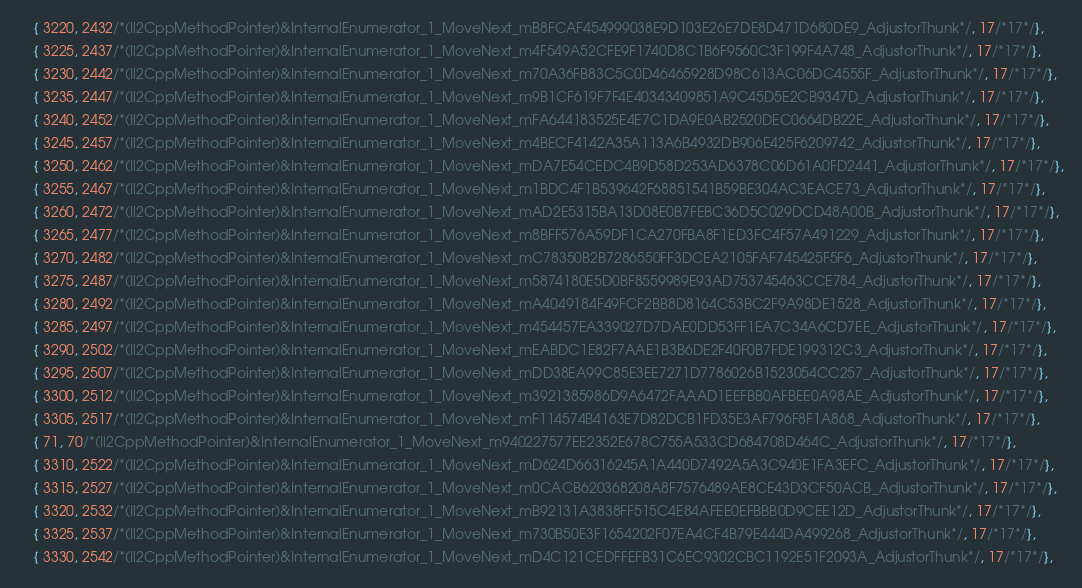Convert code to text. <code><loc_0><loc_0><loc_500><loc_500><_C++_>	{ 3220, 2432/*(Il2CppMethodPointer)&InternalEnumerator_1_MoveNext_mB8FCAF454999038E9D103E26E7DE8D471D680DE9_AdjustorThunk*/, 17/*17*/},
	{ 3225, 2437/*(Il2CppMethodPointer)&InternalEnumerator_1_MoveNext_m4F549A52CFE9F1740D8C1B6F9560C3F199F4A748_AdjustorThunk*/, 17/*17*/},
	{ 3230, 2442/*(Il2CppMethodPointer)&InternalEnumerator_1_MoveNext_m70A36FB83C5C0D46465928D98C613AC06DC4555F_AdjustorThunk*/, 17/*17*/},
	{ 3235, 2447/*(Il2CppMethodPointer)&InternalEnumerator_1_MoveNext_m9B1CF619F7F4E40343409851A9C45D5E2CB9347D_AdjustorThunk*/, 17/*17*/},
	{ 3240, 2452/*(Il2CppMethodPointer)&InternalEnumerator_1_MoveNext_mFA644183525E4E7C1DA9E0AB2520DEC0664DB22E_AdjustorThunk*/, 17/*17*/},
	{ 3245, 2457/*(Il2CppMethodPointer)&InternalEnumerator_1_MoveNext_m4BECF4142A35A113A6B4932DB906E425F6209742_AdjustorThunk*/, 17/*17*/},
	{ 3250, 2462/*(Il2CppMethodPointer)&InternalEnumerator_1_MoveNext_mDA7E54CEDC4B9D58D253AD6378C06D61A0FD2441_AdjustorThunk*/, 17/*17*/},
	{ 3255, 2467/*(Il2CppMethodPointer)&InternalEnumerator_1_MoveNext_m1BDC4F1B539642F68851541B59BE304AC3EACE73_AdjustorThunk*/, 17/*17*/},
	{ 3260, 2472/*(Il2CppMethodPointer)&InternalEnumerator_1_MoveNext_mAD2E5315BA13D08E0B7FEBC36D5C029DCD48A00B_AdjustorThunk*/, 17/*17*/},
	{ 3265, 2477/*(Il2CppMethodPointer)&InternalEnumerator_1_MoveNext_m8BFF576A59DF1CA270FBA8F1ED3FC4F57A491229_AdjustorThunk*/, 17/*17*/},
	{ 3270, 2482/*(Il2CppMethodPointer)&InternalEnumerator_1_MoveNext_mC78350B2B7286550FF3DCEA2105FAF745425F5F6_AdjustorThunk*/, 17/*17*/},
	{ 3275, 2487/*(Il2CppMethodPointer)&InternalEnumerator_1_MoveNext_m5874180E5D0BF8559989E93AD753745463CCE784_AdjustorThunk*/, 17/*17*/},
	{ 3280, 2492/*(Il2CppMethodPointer)&InternalEnumerator_1_MoveNext_mA4049184F49FCF2BB8D8164C53BC2F9A98DE1528_AdjustorThunk*/, 17/*17*/},
	{ 3285, 2497/*(Il2CppMethodPointer)&InternalEnumerator_1_MoveNext_m454457EA339027D7DAE0DD53FF1EA7C34A6CD7EE_AdjustorThunk*/, 17/*17*/},
	{ 3290, 2502/*(Il2CppMethodPointer)&InternalEnumerator_1_MoveNext_mEABDC1E82F7AAE1B3B6DE2F40F0B7FDE199312C3_AdjustorThunk*/, 17/*17*/},
	{ 3295, 2507/*(Il2CppMethodPointer)&InternalEnumerator_1_MoveNext_mDD38EA99C85E3EE7271D7786026B1523054CC257_AdjustorThunk*/, 17/*17*/},
	{ 3300, 2512/*(Il2CppMethodPointer)&InternalEnumerator_1_MoveNext_m3921385986D9A6472FAAAD1EEFBB0AFBEE0A98AE_AdjustorThunk*/, 17/*17*/},
	{ 3305, 2517/*(Il2CppMethodPointer)&InternalEnumerator_1_MoveNext_mF114574B4163E7D82DCB1FD35E3AF796F8F1A868_AdjustorThunk*/, 17/*17*/},
	{ 71, 70/*(Il2CppMethodPointer)&InternalEnumerator_1_MoveNext_m940227577EE2352E678C755A533CD684708D464C_AdjustorThunk*/, 17/*17*/},
	{ 3310, 2522/*(Il2CppMethodPointer)&InternalEnumerator_1_MoveNext_mD624D66316245A1A440D7492A5A3C940E1FA3EFC_AdjustorThunk*/, 17/*17*/},
	{ 3315, 2527/*(Il2CppMethodPointer)&InternalEnumerator_1_MoveNext_m0CACB620368208A8F7576489AE8CE43D3CF50ACB_AdjustorThunk*/, 17/*17*/},
	{ 3320, 2532/*(Il2CppMethodPointer)&InternalEnumerator_1_MoveNext_mB92131A3838FF515C4E84AFEE0EFBBB0D9CEE12D_AdjustorThunk*/, 17/*17*/},
	{ 3325, 2537/*(Il2CppMethodPointer)&InternalEnumerator_1_MoveNext_m730B50E3F1654202F07EA4CF4B79E444DA499268_AdjustorThunk*/, 17/*17*/},
	{ 3330, 2542/*(Il2CppMethodPointer)&InternalEnumerator_1_MoveNext_mD4C121CEDFFEFB31C6EC9302CBC1192E51F2093A_AdjustorThunk*/, 17/*17*/},</code> 